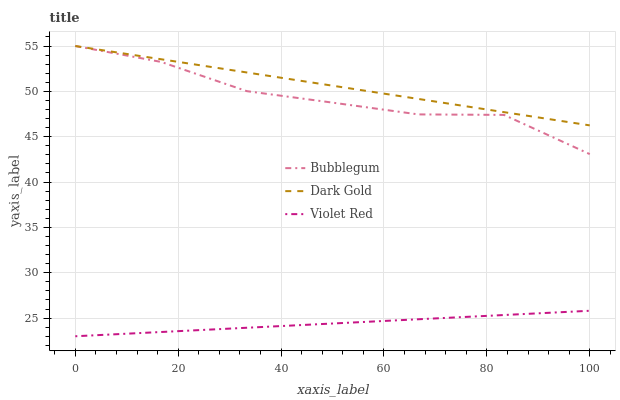Does Violet Red have the minimum area under the curve?
Answer yes or no. Yes. Does Dark Gold have the maximum area under the curve?
Answer yes or no. Yes. Does Bubblegum have the minimum area under the curve?
Answer yes or no. No. Does Bubblegum have the maximum area under the curve?
Answer yes or no. No. Is Violet Red the smoothest?
Answer yes or no. Yes. Is Bubblegum the roughest?
Answer yes or no. Yes. Is Dark Gold the smoothest?
Answer yes or no. No. Is Dark Gold the roughest?
Answer yes or no. No. Does Violet Red have the lowest value?
Answer yes or no. Yes. Does Bubblegum have the lowest value?
Answer yes or no. No. Does Dark Gold have the highest value?
Answer yes or no. Yes. Is Violet Red less than Bubblegum?
Answer yes or no. Yes. Is Bubblegum greater than Violet Red?
Answer yes or no. Yes. Does Bubblegum intersect Dark Gold?
Answer yes or no. Yes. Is Bubblegum less than Dark Gold?
Answer yes or no. No. Is Bubblegum greater than Dark Gold?
Answer yes or no. No. Does Violet Red intersect Bubblegum?
Answer yes or no. No. 